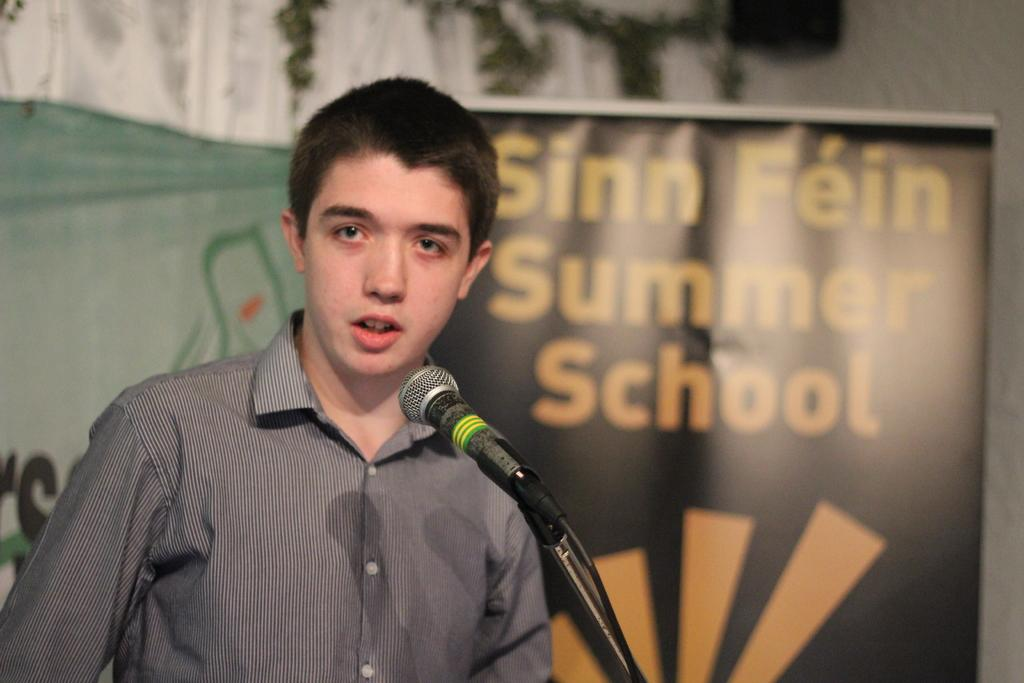What is the person in the image doing? The person is standing in front of a mic. What else can be seen in the image besides the person? There are banners with text and a wall visible in the background of the image. Where is the faucet located in the image? There is no faucet present in the image. What type of roof is visible in the image? There is no roof visible in the image. 